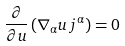<formula> <loc_0><loc_0><loc_500><loc_500>\frac { \partial } { \partial u } \, ( \nabla _ { \alpha } u \, { j ^ { \alpha } } ) = 0</formula> 